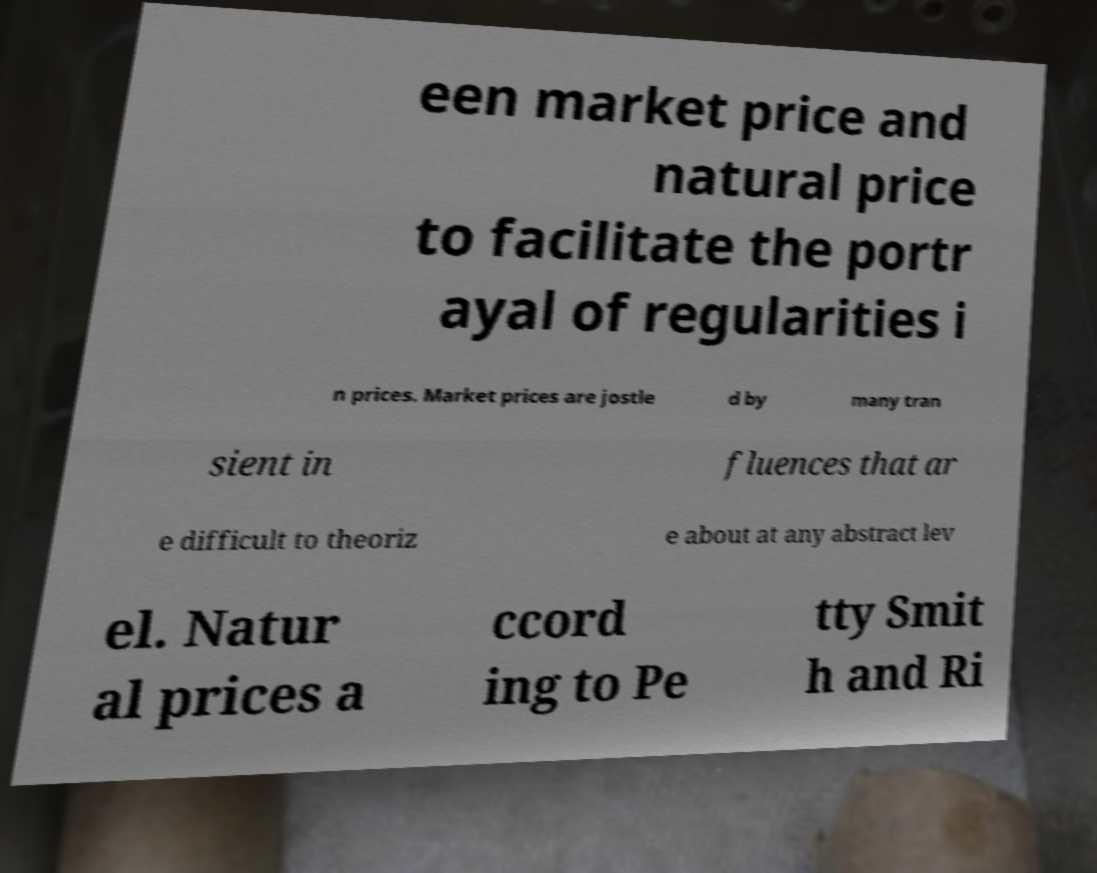Could you assist in decoding the text presented in this image and type it out clearly? een market price and natural price to facilitate the portr ayal of regularities i n prices. Market prices are jostle d by many tran sient in fluences that ar e difficult to theoriz e about at any abstract lev el. Natur al prices a ccord ing to Pe tty Smit h and Ri 